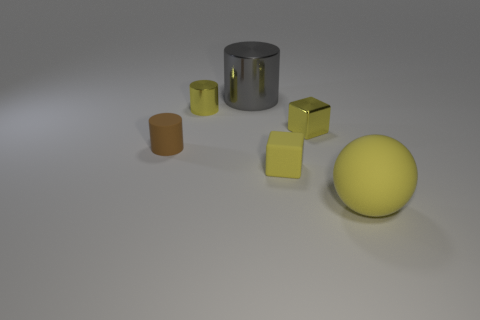Are there any small blue balls that have the same material as the large gray thing?
Your response must be concise. No. Does the matte cube have the same size as the yellow metal cylinder?
Your answer should be very brief. Yes. How many balls are small yellow matte things or large shiny objects?
Make the answer very short. 0. There is a cylinder that is the same color as the big sphere; what is its material?
Provide a short and direct response. Metal. How many other yellow things have the same shape as the small yellow matte object?
Provide a short and direct response. 1. Are there more large balls that are left of the gray shiny cylinder than yellow things that are left of the yellow ball?
Provide a short and direct response. No. There is a small object right of the tiny yellow matte thing; is its color the same as the rubber cylinder?
Your response must be concise. No. The gray shiny thing has what size?
Your response must be concise. Large. What is the material of the brown cylinder that is the same size as the yellow metal cube?
Offer a very short reply. Rubber. There is a small object to the left of the small yellow metal cylinder; what color is it?
Your response must be concise. Brown. 